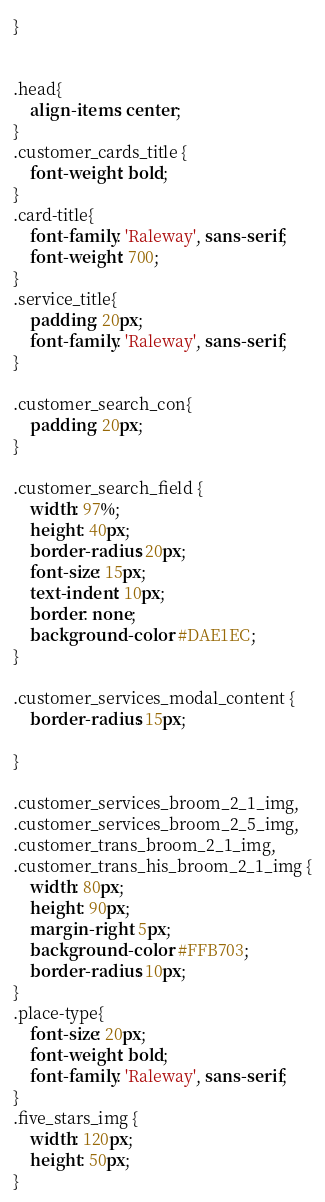Convert code to text. <code><loc_0><loc_0><loc_500><loc_500><_CSS_>}


.head{
    align-items: center;
}
.customer_cards_title {
    font-weight: bold;
}
.card-title{
    font-family: 'Raleway', sans-serif;
    font-weight: 700;
}
.service_title{
    padding: 20px;
    font-family: 'Raleway', sans-serif;
}

.customer_search_con{
    padding: 20px;
}

.customer_search_field {
    width: 97%;
    height: 40px;
    border-radius: 20px; 
    font-size: 15px;
    text-indent: 10px;
    border: none;
    background-color: #DAE1EC;
}

.customer_services_modal_content {
    border-radius: 15px;
    
}

.customer_services_broom_2_1_img, 
.customer_services_broom_2_5_img,
.customer_trans_broom_2_1_img,
.customer_trans_his_broom_2_1_img {
    width: 80px;
    height: 90px;
    margin-right: 5px; 
    background-color: #FFB703;  
    border-radius: 10px; 
}
.place-type{
    font-size: 20px;
    font-weight: bold;
    font-family: 'Raleway', sans-serif;
}
.five_stars_img {
    width: 120px;
    height: 50px;
}</code> 